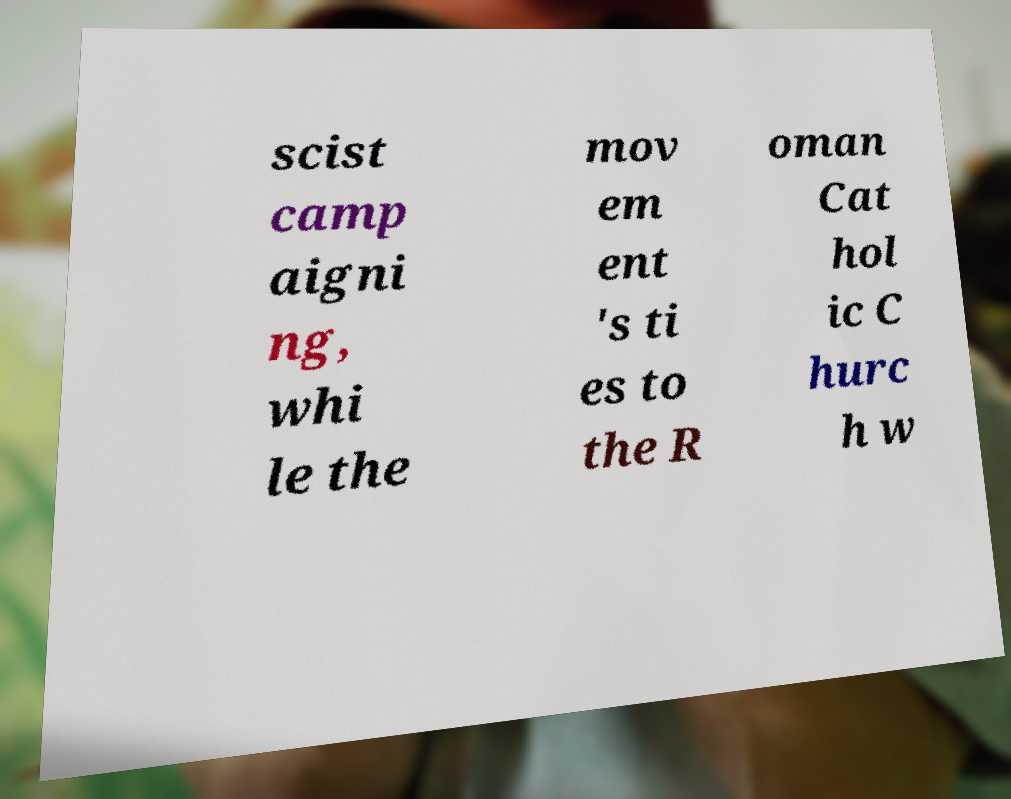Can you accurately transcribe the text from the provided image for me? scist camp aigni ng, whi le the mov em ent 's ti es to the R oman Cat hol ic C hurc h w 